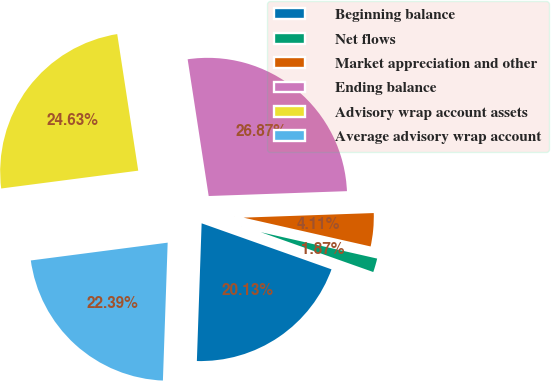Convert chart to OTSL. <chart><loc_0><loc_0><loc_500><loc_500><pie_chart><fcel>Beginning balance<fcel>Net flows<fcel>Market appreciation and other<fcel>Ending balance<fcel>Advisory wrap account assets<fcel>Average advisory wrap account<nl><fcel>20.13%<fcel>1.87%<fcel>4.11%<fcel>26.87%<fcel>24.63%<fcel>22.39%<nl></chart> 